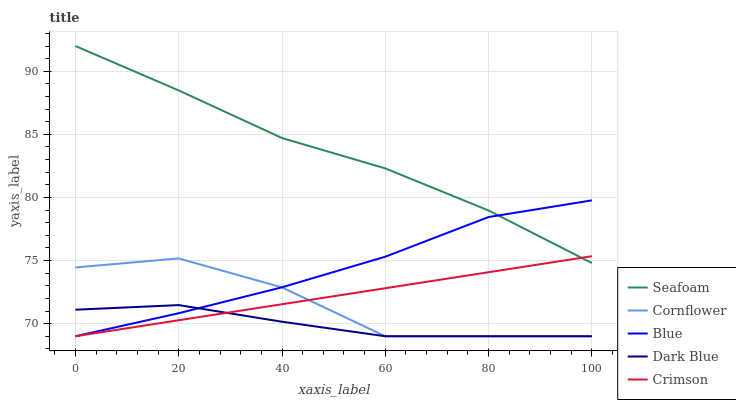Does Cornflower have the minimum area under the curve?
Answer yes or no. No. Does Cornflower have the maximum area under the curve?
Answer yes or no. No. Is Seafoam the smoothest?
Answer yes or no. No. Is Seafoam the roughest?
Answer yes or no. No. Does Seafoam have the lowest value?
Answer yes or no. No. Does Cornflower have the highest value?
Answer yes or no. No. Is Cornflower less than Seafoam?
Answer yes or no. Yes. Is Seafoam greater than Dark Blue?
Answer yes or no. Yes. Does Cornflower intersect Seafoam?
Answer yes or no. No. 